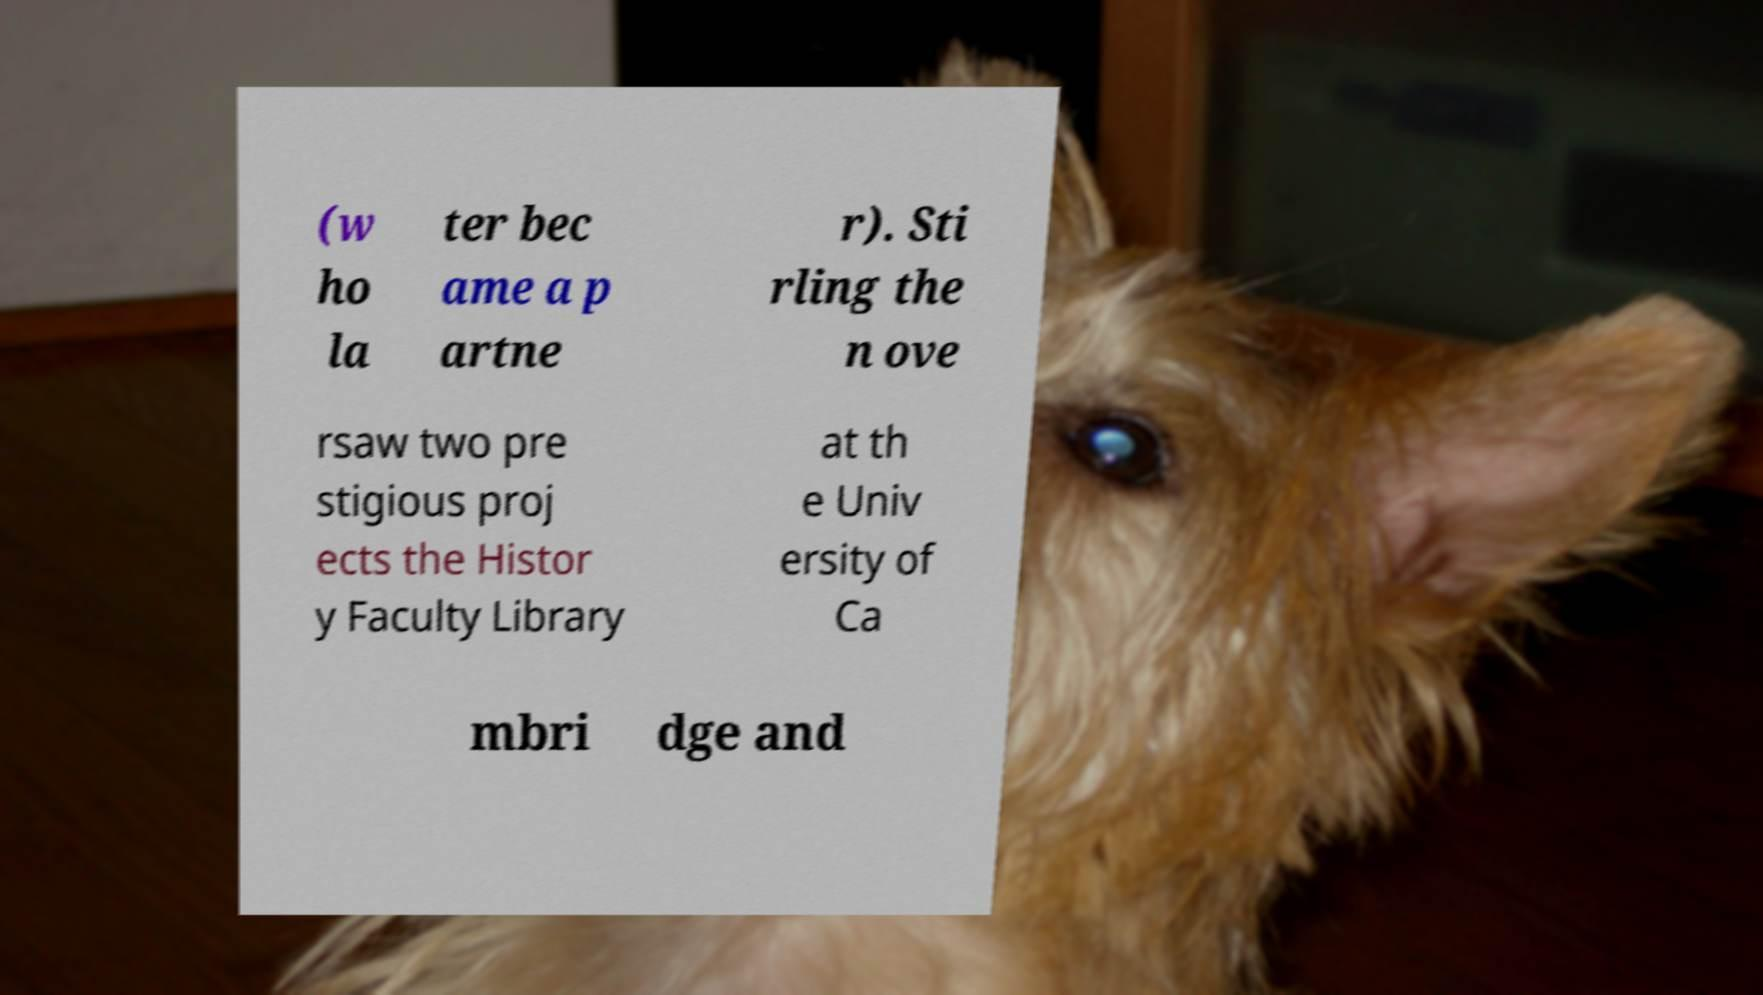Could you assist in decoding the text presented in this image and type it out clearly? (w ho la ter bec ame a p artne r). Sti rling the n ove rsaw two pre stigious proj ects the Histor y Faculty Library at th e Univ ersity of Ca mbri dge and 